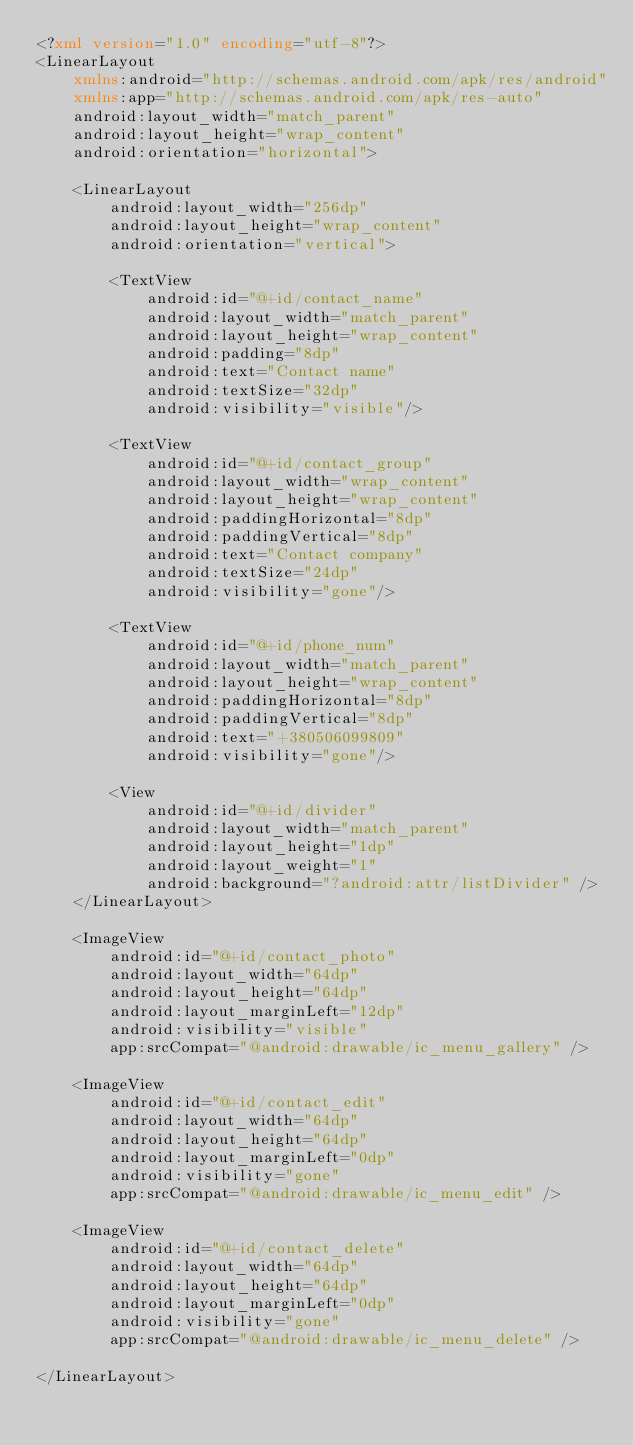Convert code to text. <code><loc_0><loc_0><loc_500><loc_500><_XML_><?xml version="1.0" encoding="utf-8"?>
<LinearLayout
    xmlns:android="http://schemas.android.com/apk/res/android"
    xmlns:app="http://schemas.android.com/apk/res-auto"
    android:layout_width="match_parent"
    android:layout_height="wrap_content"
    android:orientation="horizontal">

    <LinearLayout
        android:layout_width="256dp"
        android:layout_height="wrap_content"
        android:orientation="vertical">

        <TextView
            android:id="@+id/contact_name"
            android:layout_width="match_parent"
            android:layout_height="wrap_content"
            android:padding="8dp"
            android:text="Contact name"
            android:textSize="32dp"
            android:visibility="visible"/>

        <TextView
            android:id="@+id/contact_group"
            android:layout_width="wrap_content"
            android:layout_height="wrap_content"
            android:paddingHorizontal="8dp"
            android:paddingVertical="8dp"
            android:text="Contact company"
            android:textSize="24dp"
            android:visibility="gone"/>

        <TextView
            android:id="@+id/phone_num"
            android:layout_width="match_parent"
            android:layout_height="wrap_content"
            android:paddingHorizontal="8dp"
            android:paddingVertical="8dp"
            android:text="+380506099809"
            android:visibility="gone"/>

        <View
            android:id="@+id/divider"
            android:layout_width="match_parent"
            android:layout_height="1dp"
            android:layout_weight="1"
            android:background="?android:attr/listDivider" />
    </LinearLayout>

    <ImageView
        android:id="@+id/contact_photo"
        android:layout_width="64dp"
        android:layout_height="64dp"
        android:layout_marginLeft="12dp"
        android:visibility="visible"
        app:srcCompat="@android:drawable/ic_menu_gallery" />

    <ImageView
        android:id="@+id/contact_edit"
        android:layout_width="64dp"
        android:layout_height="64dp"
        android:layout_marginLeft="0dp"
        android:visibility="gone"
        app:srcCompat="@android:drawable/ic_menu_edit" />

    <ImageView
        android:id="@+id/contact_delete"
        android:layout_width="64dp"
        android:layout_height="64dp"
        android:layout_marginLeft="0dp"
        android:visibility="gone"
        app:srcCompat="@android:drawable/ic_menu_delete" />

</LinearLayout></code> 